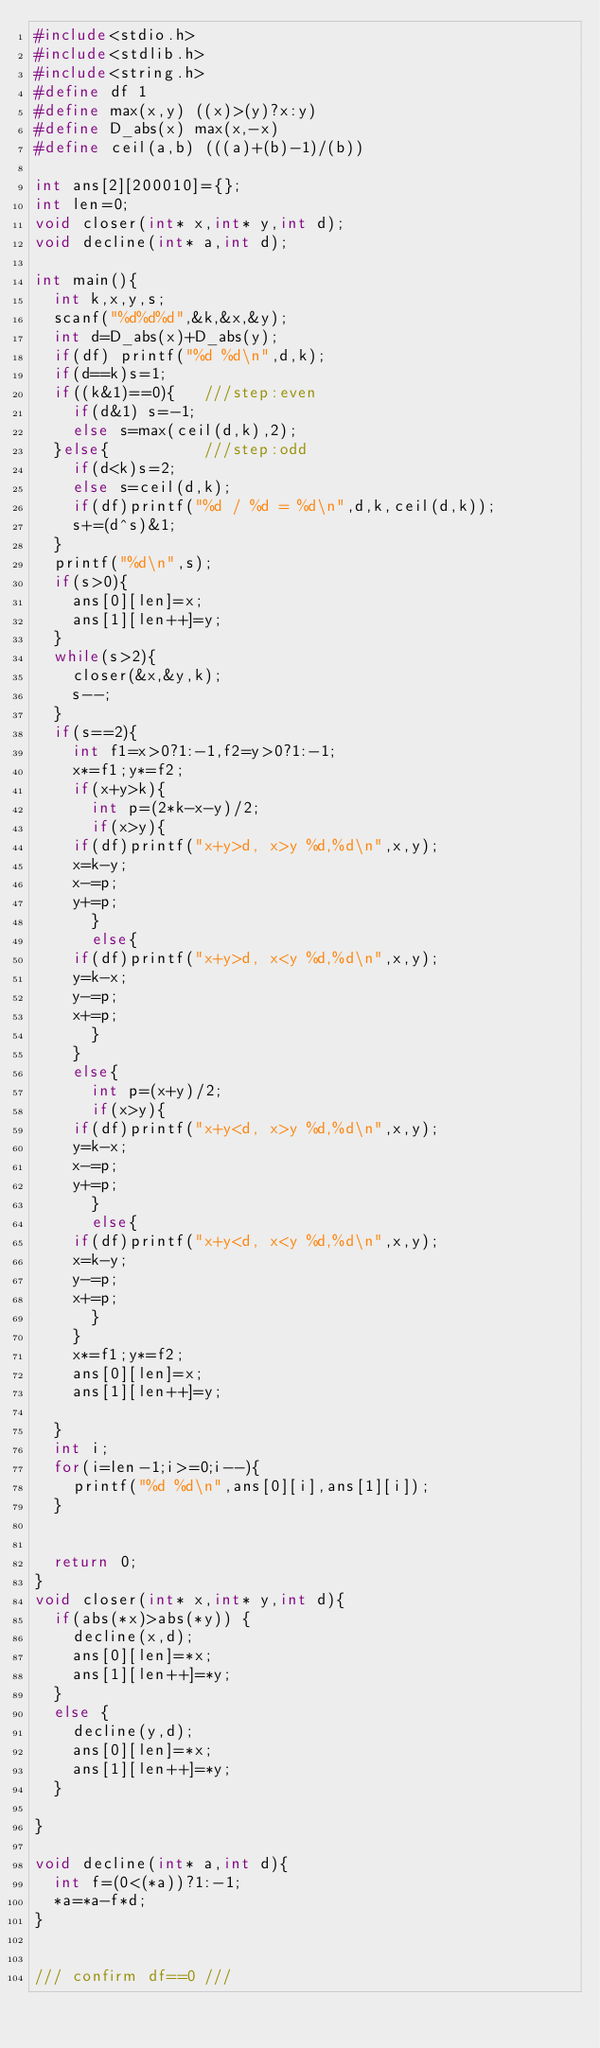<code> <loc_0><loc_0><loc_500><loc_500><_C_>#include<stdio.h>
#include<stdlib.h>
#include<string.h>
#define df 1
#define max(x,y) ((x)>(y)?x:y)
#define D_abs(x) max(x,-x)
#define ceil(a,b) (((a)+(b)-1)/(b))

int ans[2][200010]={};
int len=0;
void closer(int* x,int* y,int d);
void decline(int* a,int d);

int main(){
  int k,x,y,s;
  scanf("%d%d%d",&k,&x,&y);
  int d=D_abs(x)+D_abs(y);
  if(df) printf("%d %d\n",d,k);
  if(d==k)s=1;
  if((k&1)==0){   ///step:even
    if(d&1) s=-1;
    else s=max(ceil(d,k),2);
  }else{          ///step:odd
    if(d<k)s=2;
    else s=ceil(d,k);
    if(df)printf("%d / %d = %d\n",d,k,ceil(d,k));
    s+=(d^s)&1;
  }
  printf("%d\n",s);
  if(s>0){
    ans[0][len]=x;
    ans[1][len++]=y;
  }
  while(s>2){
    closer(&x,&y,k);
    s--;
  }
  if(s==2){
    int f1=x>0?1:-1,f2=y>0?1:-1;
    x*=f1;y*=f2;
    if(x+y>k){
      int p=(2*k-x-y)/2;
      if(x>y){
	if(df)printf("x+y>d, x>y %d,%d\n",x,y);
	x=k-y;
	x-=p;
	y+=p;
      }
      else{
	if(df)printf("x+y>d, x<y %d,%d\n",x,y);
	y=k-x;
	y-=p;
	x+=p;
      }
    }
    else{
      int p=(x+y)/2;
      if(x>y){
	if(df)printf("x+y<d, x>y %d,%d\n",x,y);
	y=k-x;
	x-=p;
	y+=p;
      }
      else{
	if(df)printf("x+y<d, x<y %d,%d\n",x,y);
	x=k-y;
	y-=p;
	x+=p;
      }
    }
    x*=f1;y*=f2;
    ans[0][len]=x;
    ans[1][len++]=y;
    
  }
  int i;
  for(i=len-1;i>=0;i--){
    printf("%d %d\n",ans[0][i],ans[1][i]);
  }


  return 0;
}
void closer(int* x,int* y,int d){
  if(abs(*x)>abs(*y)) {
    decline(x,d);
    ans[0][len]=*x;
    ans[1][len++]=*y;
  }
  else {
    decline(y,d);
    ans[0][len]=*x;
    ans[1][len++]=*y;
  }
  
}

void decline(int* a,int d){
  int f=(0<(*a))?1:-1;
  *a=*a-f*d;
}


/// confirm df==0 ///
</code> 